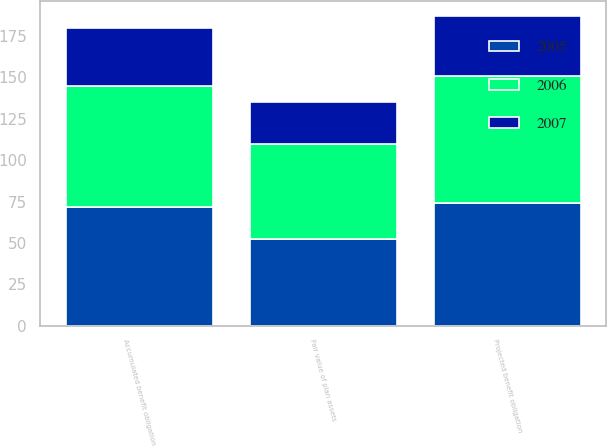Convert chart. <chart><loc_0><loc_0><loc_500><loc_500><stacked_bar_chart><ecel><fcel>Projected benefit obligation<fcel>Accumulated benefit obligation<fcel>Fair value of plan assets<nl><fcel>2007<fcel>35.7<fcel>34.9<fcel>25.2<nl><fcel>2006<fcel>77.1<fcel>73.3<fcel>57.6<nl><fcel>2005<fcel>74<fcel>71.5<fcel>52.3<nl></chart> 